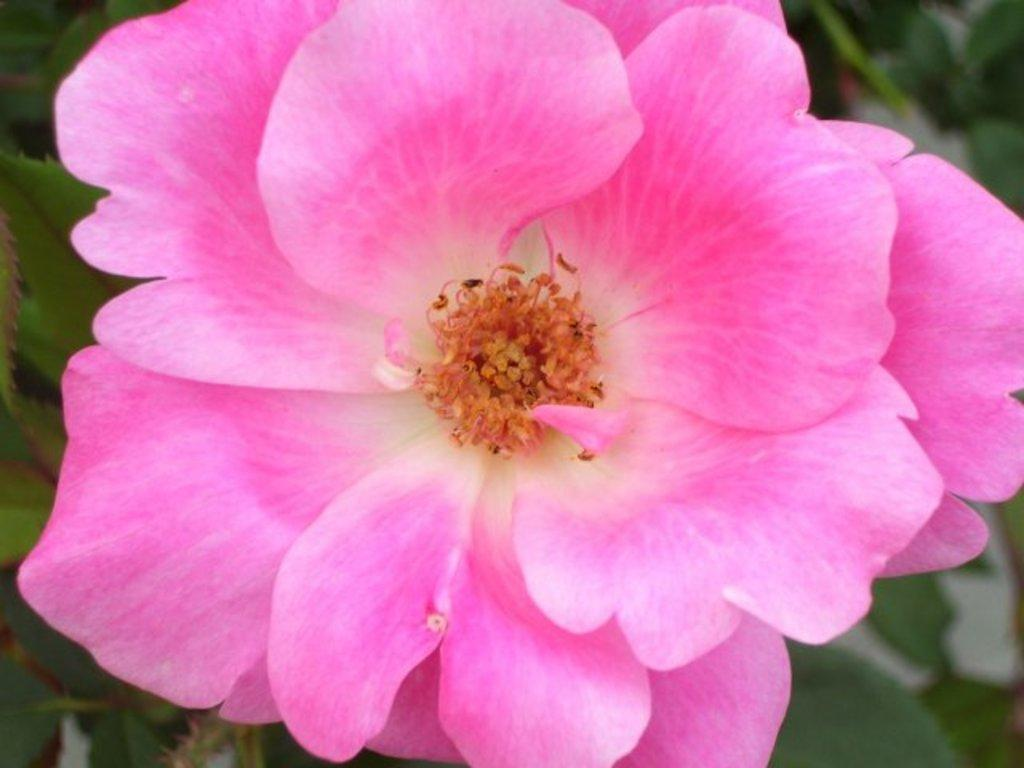What type of flower is in the image? There is a pink color flower in the image. Can you describe the background of the image? The background of the image is blurry. How many glasses of juice are visible in the image? There is no mention of juice or glasses in the image, so it is not possible to answer that question. 